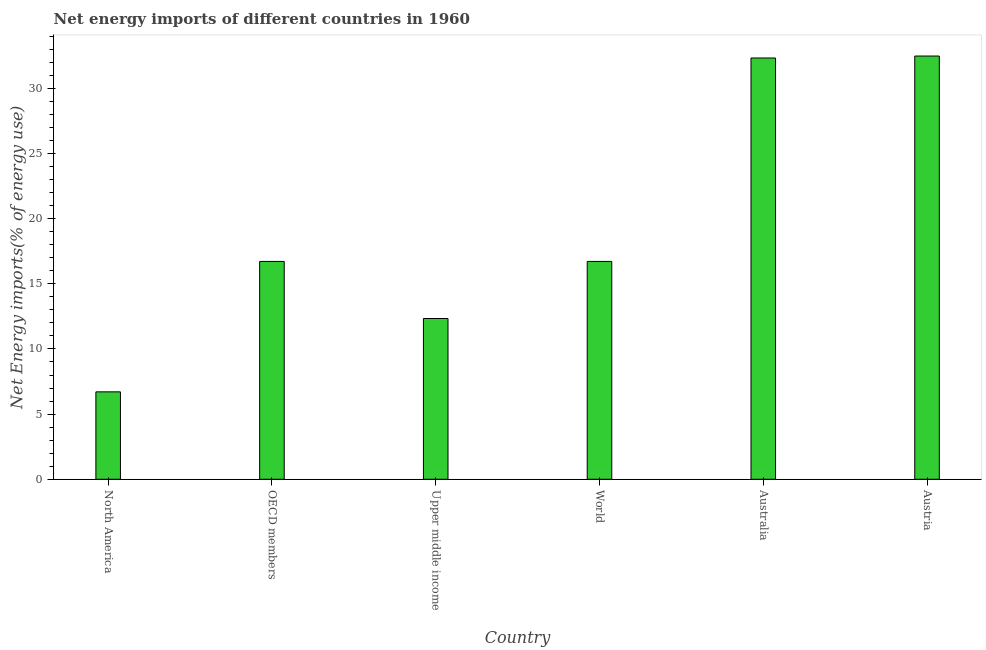Does the graph contain any zero values?
Your response must be concise. No. Does the graph contain grids?
Ensure brevity in your answer.  No. What is the title of the graph?
Your answer should be compact. Net energy imports of different countries in 1960. What is the label or title of the Y-axis?
Your answer should be compact. Net Energy imports(% of energy use). What is the energy imports in North America?
Your response must be concise. 6.71. Across all countries, what is the maximum energy imports?
Give a very brief answer. 32.48. Across all countries, what is the minimum energy imports?
Provide a short and direct response. 6.71. What is the sum of the energy imports?
Make the answer very short. 117.28. What is the difference between the energy imports in North America and World?
Your answer should be very brief. -10.01. What is the average energy imports per country?
Your answer should be very brief. 19.55. What is the median energy imports?
Provide a succinct answer. 16.72. In how many countries, is the energy imports greater than 13 %?
Provide a short and direct response. 4. What is the ratio of the energy imports in Austria to that in Upper middle income?
Offer a terse response. 2.63. Is the energy imports in Austria less than that in OECD members?
Offer a terse response. No. What is the difference between the highest and the second highest energy imports?
Your response must be concise. 0.15. What is the difference between the highest and the lowest energy imports?
Give a very brief answer. 25.77. Are all the bars in the graph horizontal?
Give a very brief answer. No. What is the Net Energy imports(% of energy use) of North America?
Provide a succinct answer. 6.71. What is the Net Energy imports(% of energy use) in OECD members?
Your answer should be very brief. 16.72. What is the Net Energy imports(% of energy use) of Upper middle income?
Your answer should be compact. 12.34. What is the Net Energy imports(% of energy use) of World?
Keep it short and to the point. 16.72. What is the Net Energy imports(% of energy use) of Australia?
Make the answer very short. 32.33. What is the Net Energy imports(% of energy use) in Austria?
Your answer should be very brief. 32.48. What is the difference between the Net Energy imports(% of energy use) in North America and OECD members?
Give a very brief answer. -10.01. What is the difference between the Net Energy imports(% of energy use) in North America and Upper middle income?
Offer a terse response. -5.63. What is the difference between the Net Energy imports(% of energy use) in North America and World?
Give a very brief answer. -10.01. What is the difference between the Net Energy imports(% of energy use) in North America and Australia?
Provide a short and direct response. -25.62. What is the difference between the Net Energy imports(% of energy use) in North America and Austria?
Offer a very short reply. -25.77. What is the difference between the Net Energy imports(% of energy use) in OECD members and Upper middle income?
Ensure brevity in your answer.  4.38. What is the difference between the Net Energy imports(% of energy use) in OECD members and World?
Provide a short and direct response. 0. What is the difference between the Net Energy imports(% of energy use) in OECD members and Australia?
Your answer should be very brief. -15.61. What is the difference between the Net Energy imports(% of energy use) in OECD members and Austria?
Keep it short and to the point. -15.76. What is the difference between the Net Energy imports(% of energy use) in Upper middle income and World?
Your answer should be compact. -4.38. What is the difference between the Net Energy imports(% of energy use) in Upper middle income and Australia?
Your answer should be very brief. -19.99. What is the difference between the Net Energy imports(% of energy use) in Upper middle income and Austria?
Provide a short and direct response. -20.14. What is the difference between the Net Energy imports(% of energy use) in World and Australia?
Provide a short and direct response. -15.61. What is the difference between the Net Energy imports(% of energy use) in World and Austria?
Offer a very short reply. -15.76. What is the difference between the Net Energy imports(% of energy use) in Australia and Austria?
Make the answer very short. -0.15. What is the ratio of the Net Energy imports(% of energy use) in North America to that in OECD members?
Provide a short and direct response. 0.4. What is the ratio of the Net Energy imports(% of energy use) in North America to that in Upper middle income?
Your answer should be very brief. 0.54. What is the ratio of the Net Energy imports(% of energy use) in North America to that in World?
Your response must be concise. 0.4. What is the ratio of the Net Energy imports(% of energy use) in North America to that in Australia?
Make the answer very short. 0.21. What is the ratio of the Net Energy imports(% of energy use) in North America to that in Austria?
Your answer should be very brief. 0.21. What is the ratio of the Net Energy imports(% of energy use) in OECD members to that in Upper middle income?
Give a very brief answer. 1.35. What is the ratio of the Net Energy imports(% of energy use) in OECD members to that in World?
Provide a succinct answer. 1. What is the ratio of the Net Energy imports(% of energy use) in OECD members to that in Australia?
Keep it short and to the point. 0.52. What is the ratio of the Net Energy imports(% of energy use) in OECD members to that in Austria?
Keep it short and to the point. 0.52. What is the ratio of the Net Energy imports(% of energy use) in Upper middle income to that in World?
Keep it short and to the point. 0.74. What is the ratio of the Net Energy imports(% of energy use) in Upper middle income to that in Australia?
Provide a short and direct response. 0.38. What is the ratio of the Net Energy imports(% of energy use) in Upper middle income to that in Austria?
Your answer should be very brief. 0.38. What is the ratio of the Net Energy imports(% of energy use) in World to that in Australia?
Offer a very short reply. 0.52. What is the ratio of the Net Energy imports(% of energy use) in World to that in Austria?
Offer a terse response. 0.52. 